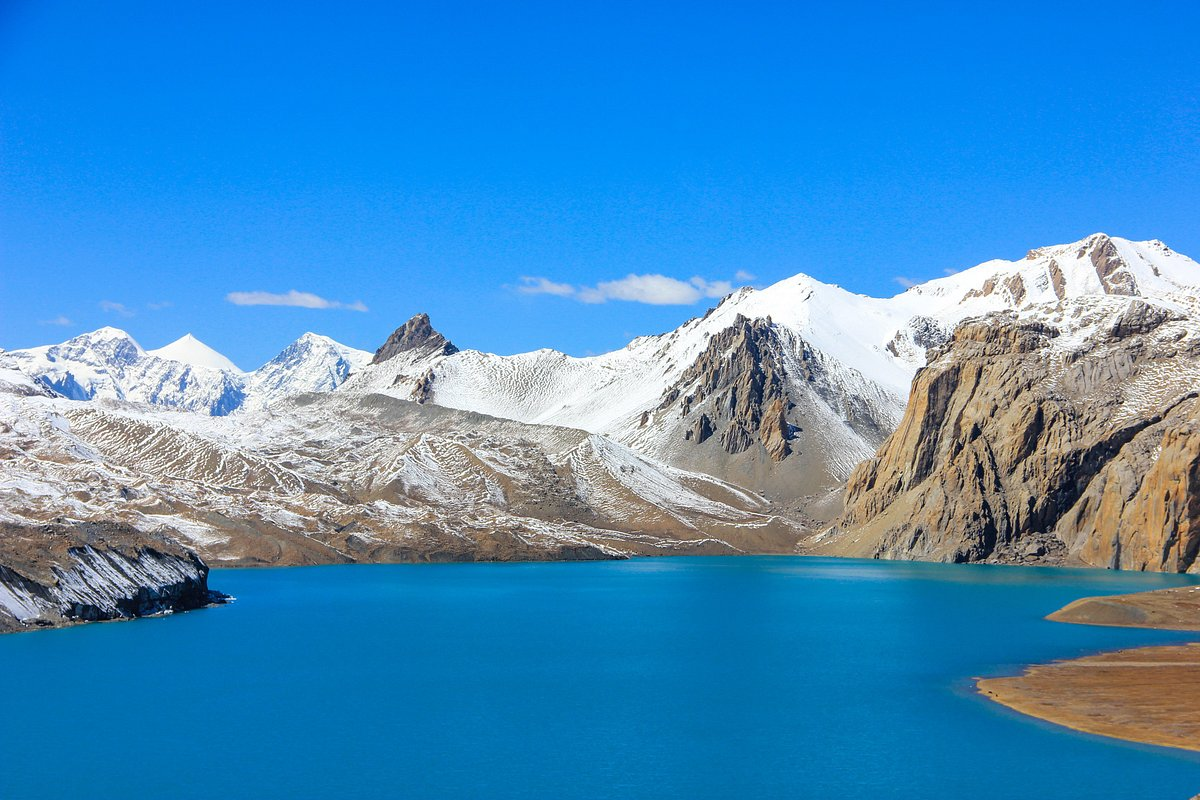Can you explain why the water has such a bright blue color? The bright blue color of the water is often a characteristic of glacial lakes. This intense blue hue results from glacial flour, which is finely ground rock particles created by glaciers grinding down rocks as they move. These particles are suspended in the water and reflect sunlight, giving the lake its vivid turquoise or blue appearance. The surrounding mountains, likely containing glaciers or snowfields, are the source of this glacial flour, as well as the meltwater that feeds the lake. 